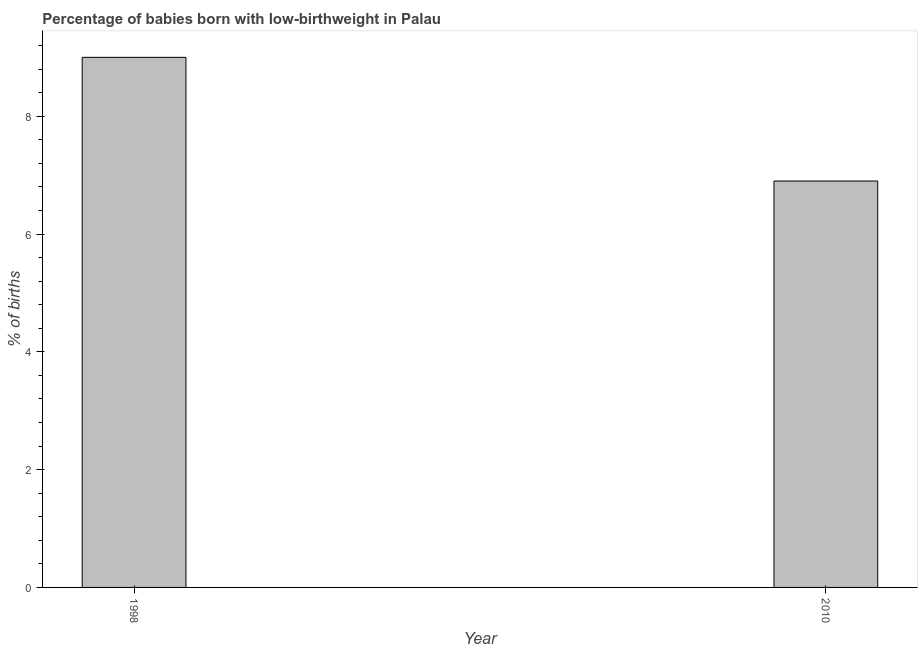Does the graph contain grids?
Your answer should be very brief. No. What is the title of the graph?
Give a very brief answer. Percentage of babies born with low-birthweight in Palau. What is the label or title of the X-axis?
Give a very brief answer. Year. What is the label or title of the Y-axis?
Your answer should be very brief. % of births. Across all years, what is the maximum percentage of babies who were born with low-birthweight?
Provide a succinct answer. 9. Across all years, what is the minimum percentage of babies who were born with low-birthweight?
Give a very brief answer. 6.9. What is the difference between the percentage of babies who were born with low-birthweight in 1998 and 2010?
Keep it short and to the point. 2.1. What is the average percentage of babies who were born with low-birthweight per year?
Make the answer very short. 7.95. What is the median percentage of babies who were born with low-birthweight?
Offer a terse response. 7.95. In how many years, is the percentage of babies who were born with low-birthweight greater than 0.8 %?
Your answer should be very brief. 2. Do a majority of the years between 1998 and 2010 (inclusive) have percentage of babies who were born with low-birthweight greater than 7.6 %?
Your answer should be very brief. No. What is the ratio of the percentage of babies who were born with low-birthweight in 1998 to that in 2010?
Your answer should be very brief. 1.3. What is the difference between the % of births in 1998 and 2010?
Offer a terse response. 2.1. What is the ratio of the % of births in 1998 to that in 2010?
Ensure brevity in your answer.  1.3. 